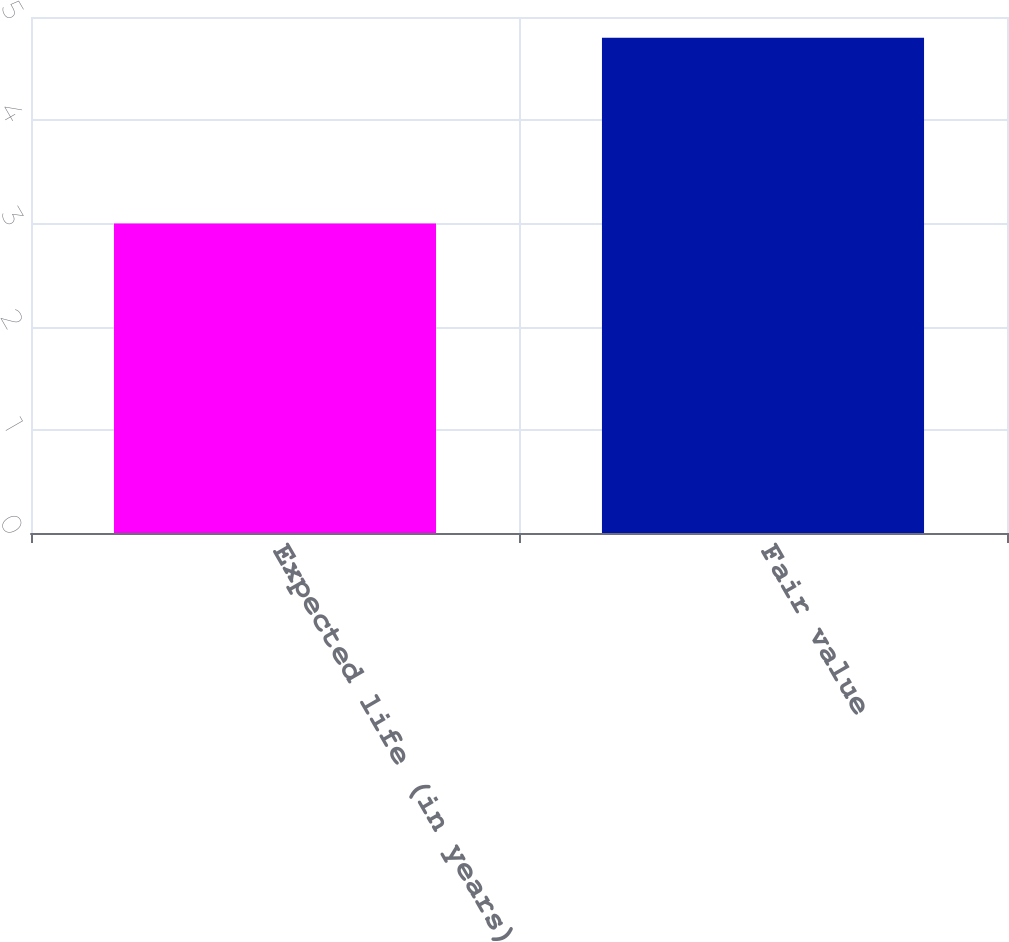Convert chart to OTSL. <chart><loc_0><loc_0><loc_500><loc_500><bar_chart><fcel>Expected life (in years)<fcel>Fair value<nl><fcel>3<fcel>4.8<nl></chart> 